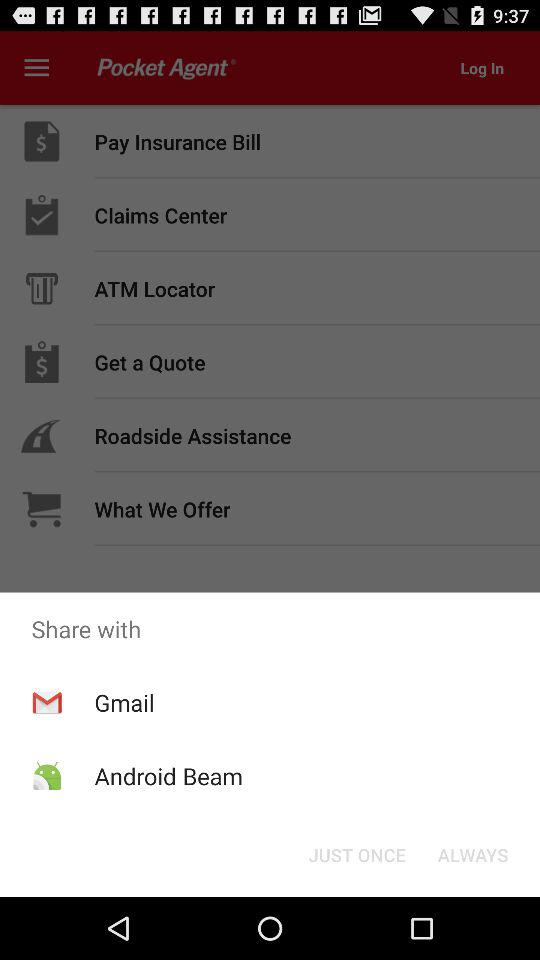What are the different sharing options? The sharing options are Gmail and Android Beam. 